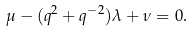<formula> <loc_0><loc_0><loc_500><loc_500>\mu - ( q ^ { 2 } + q ^ { - 2 } ) \lambda + \nu = 0 .</formula> 